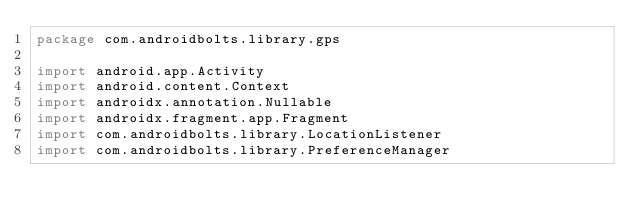<code> <loc_0><loc_0><loc_500><loc_500><_Kotlin_>package com.androidbolts.library.gps

import android.app.Activity
import android.content.Context
import androidx.annotation.Nullable
import androidx.fragment.app.Fragment
import com.androidbolts.library.LocationListener
import com.androidbolts.library.PreferenceManager</code> 